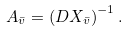<formula> <loc_0><loc_0><loc_500><loc_500>A _ { \bar { v } } = \left ( D X _ { \bar { v } } \right ) ^ { - 1 } .</formula> 